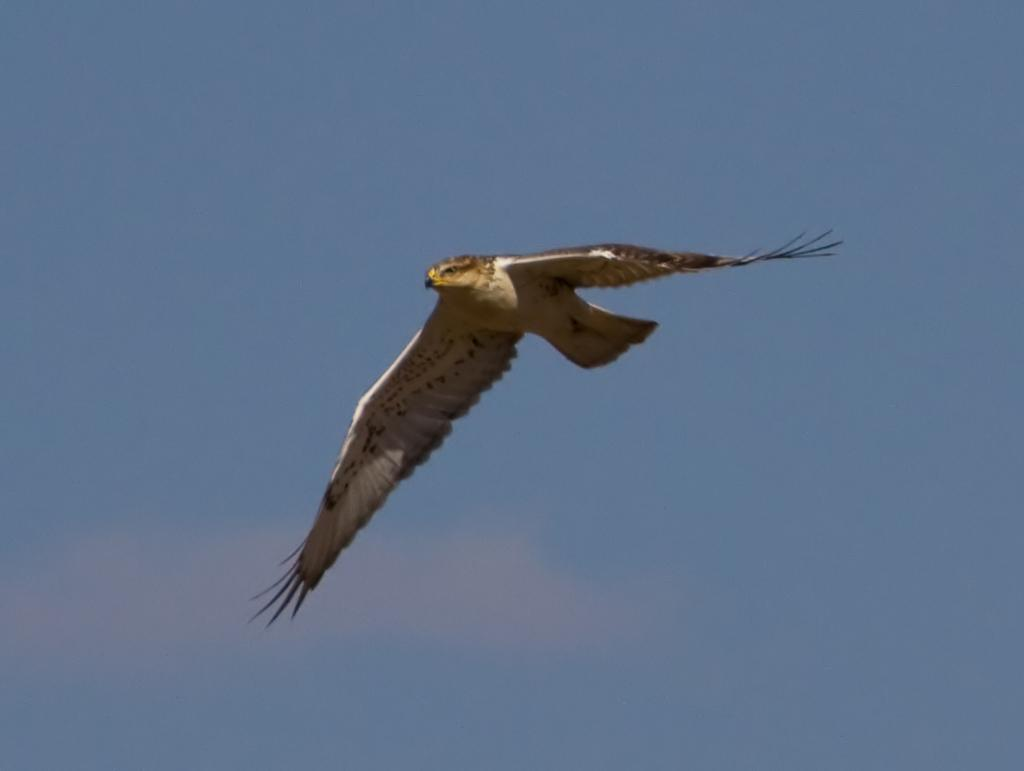What type of animal can be seen in the image? There is a bird in the image. What is the bird doing in the image? The bird is flying in the sky. What type of advertisement can be seen on the bird's wing in the image? There is no advertisement present on the bird's wing in the image, as it only features a bird flying in the sky. 